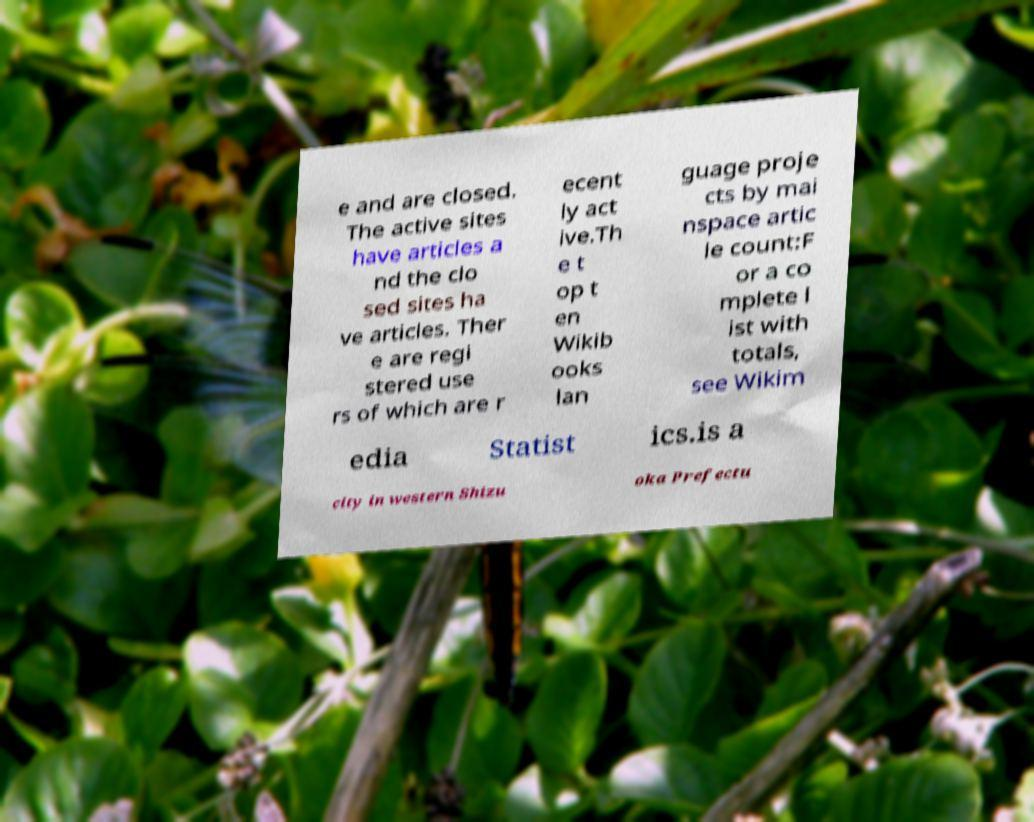I need the written content from this picture converted into text. Can you do that? e and are closed. The active sites have articles a nd the clo sed sites ha ve articles. Ther e are regi stered use rs of which are r ecent ly act ive.Th e t op t en Wikib ooks lan guage proje cts by mai nspace artic le count:F or a co mplete l ist with totals, see Wikim edia Statist ics.is a city in western Shizu oka Prefectu 